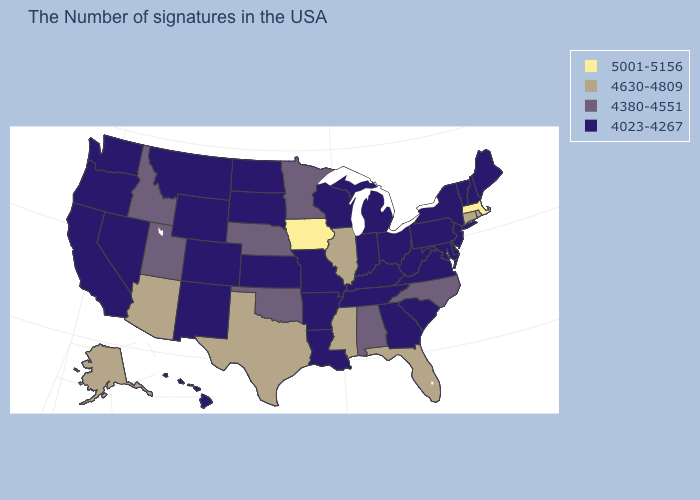What is the highest value in the MidWest ?
Be succinct. 5001-5156. What is the value of Connecticut?
Concise answer only. 4630-4809. Is the legend a continuous bar?
Short answer required. No. Among the states that border Texas , does Arkansas have the highest value?
Concise answer only. No. What is the lowest value in states that border Alabama?
Short answer required. 4023-4267. Name the states that have a value in the range 5001-5156?
Give a very brief answer. Massachusetts, Iowa. What is the highest value in the USA?
Be succinct. 5001-5156. What is the value of Iowa?
Be succinct. 5001-5156. How many symbols are there in the legend?
Quick response, please. 4. What is the highest value in the USA?
Keep it brief. 5001-5156. Name the states that have a value in the range 4380-4551?
Give a very brief answer. North Carolina, Alabama, Minnesota, Nebraska, Oklahoma, Utah, Idaho. Does Tennessee have a lower value than Indiana?
Short answer required. No. What is the value of New Jersey?
Answer briefly. 4023-4267. Among the states that border Nevada , does Arizona have the highest value?
Answer briefly. Yes. 